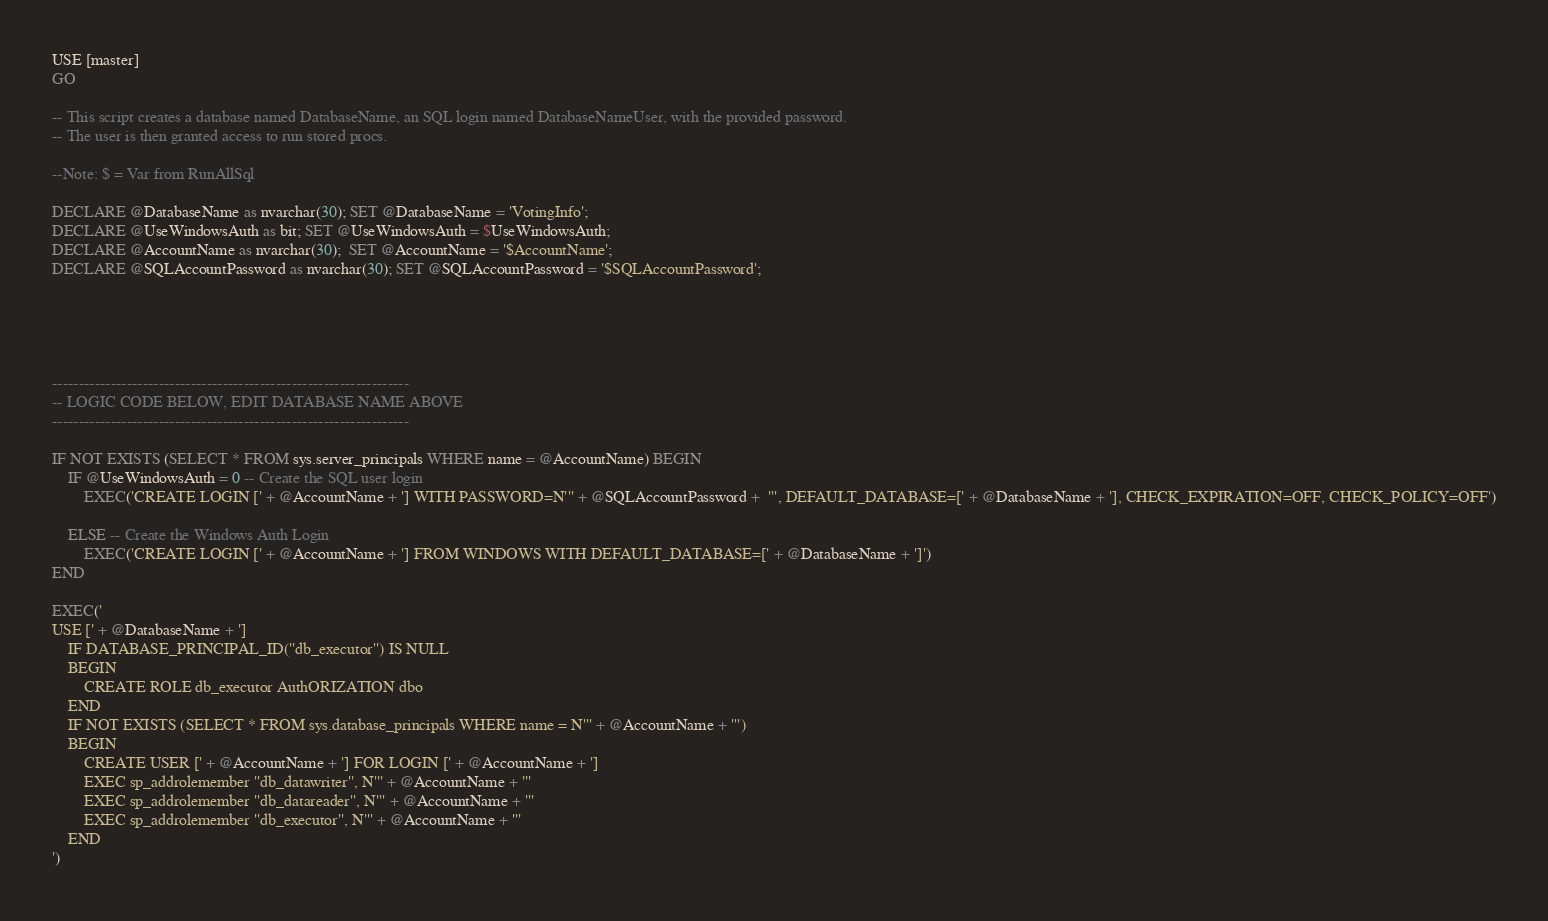<code> <loc_0><loc_0><loc_500><loc_500><_SQL_>USE [master]
GO

-- This script creates a database named DatabaseName, an SQL login named DatabaseNameUser, with the provided password.
-- The user is then granted access to run stored procs.

--Note: $ = Var from RunAllSql

DECLARE @DatabaseName as nvarchar(30); SET @DatabaseName = 'VotingInfo';
DECLARE @UseWindowsAuth as bit; SET @UseWindowsAuth = $UseWindowsAuth;
DECLARE @AccountName as nvarchar(30);  SET @AccountName = '$AccountName';
DECLARE @SQLAccountPassword as nvarchar(30); SET @SQLAccountPassword = '$SQLAccountPassword';





-------------------------------------------------------------------
-- LOGIC CODE BELOW, EDIT DATABASE NAME ABOVE
-------------------------------------------------------------------

IF NOT EXISTS (SELECT * FROM sys.server_principals WHERE name = @AccountName) BEGIN
	IF @UseWindowsAuth = 0 -- Create the SQL user login
		EXEC('CREATE LOGIN [' + @AccountName + '] WITH PASSWORD=N''' + @SQLAccountPassword +  ''', DEFAULT_DATABASE=[' + @DatabaseName + '], CHECK_EXPIRATION=OFF, CHECK_POLICY=OFF')

	ELSE -- Create the Windows Auth Login
		EXEC('CREATE LOGIN [' + @AccountName + '] FROM WINDOWS WITH DEFAULT_DATABASE=[' + @DatabaseName + ']')
END

EXEC('
USE [' + @DatabaseName + ']
	IF DATABASE_PRINCIPAL_ID(''db_executor'') IS NULL
	BEGIN 
		CREATE ROLE db_executor AuthORIZATION dbo
	END
	IF NOT EXISTS (SELECT * FROM sys.database_principals WHERE name = N''' + @AccountName + ''')
	BEGIN
		CREATE USER [' + @AccountName + '] FOR LOGIN [' + @AccountName + ']
		EXEC sp_addrolemember ''db_datawriter'', N''' + @AccountName + '''
		EXEC sp_addrolemember ''db_datareader'', N''' + @AccountName + '''
		EXEC sp_addrolemember ''db_executor'', N''' + @AccountName + '''
	END
')</code> 